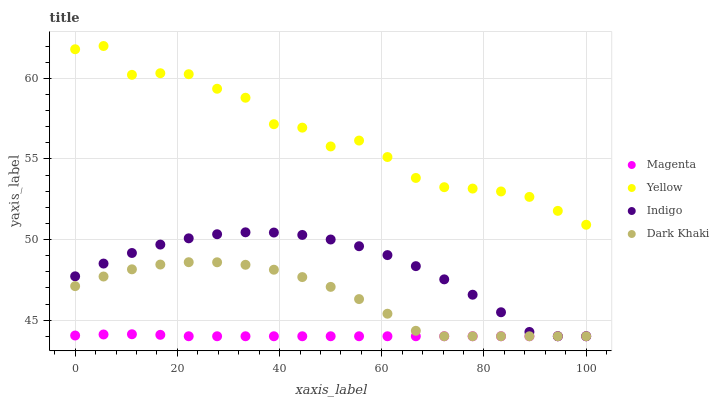Does Magenta have the minimum area under the curve?
Answer yes or no. Yes. Does Yellow have the maximum area under the curve?
Answer yes or no. Yes. Does Indigo have the minimum area under the curve?
Answer yes or no. No. Does Indigo have the maximum area under the curve?
Answer yes or no. No. Is Magenta the smoothest?
Answer yes or no. Yes. Is Yellow the roughest?
Answer yes or no. Yes. Is Indigo the smoothest?
Answer yes or no. No. Is Indigo the roughest?
Answer yes or no. No. Does Dark Khaki have the lowest value?
Answer yes or no. Yes. Does Yellow have the lowest value?
Answer yes or no. No. Does Yellow have the highest value?
Answer yes or no. Yes. Does Indigo have the highest value?
Answer yes or no. No. Is Indigo less than Yellow?
Answer yes or no. Yes. Is Yellow greater than Indigo?
Answer yes or no. Yes. Does Dark Khaki intersect Indigo?
Answer yes or no. Yes. Is Dark Khaki less than Indigo?
Answer yes or no. No. Is Dark Khaki greater than Indigo?
Answer yes or no. No. Does Indigo intersect Yellow?
Answer yes or no. No. 